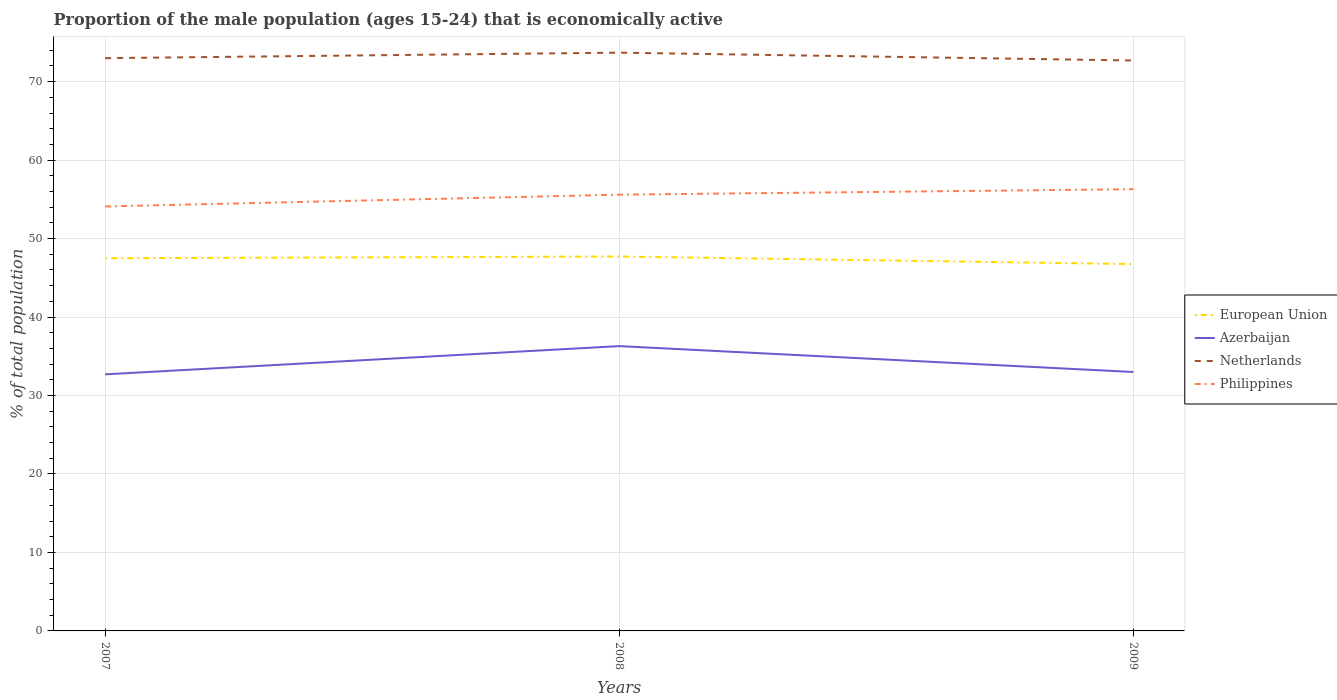How many different coloured lines are there?
Give a very brief answer. 4. Across all years, what is the maximum proportion of the male population that is economically active in Philippines?
Your response must be concise. 54.1. What is the total proportion of the male population that is economically active in Netherlands in the graph?
Your answer should be compact. -0.7. What is the difference between the highest and the second highest proportion of the male population that is economically active in Azerbaijan?
Keep it short and to the point. 3.6. Is the proportion of the male population that is economically active in Netherlands strictly greater than the proportion of the male population that is economically active in European Union over the years?
Your answer should be compact. No. What is the difference between two consecutive major ticks on the Y-axis?
Make the answer very short. 10. Does the graph contain grids?
Provide a succinct answer. Yes. How many legend labels are there?
Offer a terse response. 4. How are the legend labels stacked?
Ensure brevity in your answer.  Vertical. What is the title of the graph?
Make the answer very short. Proportion of the male population (ages 15-24) that is economically active. Does "New Zealand" appear as one of the legend labels in the graph?
Make the answer very short. No. What is the label or title of the X-axis?
Offer a very short reply. Years. What is the label or title of the Y-axis?
Provide a succinct answer. % of total population. What is the % of total population of European Union in 2007?
Give a very brief answer. 47.5. What is the % of total population in Azerbaijan in 2007?
Offer a terse response. 32.7. What is the % of total population in Philippines in 2007?
Your response must be concise. 54.1. What is the % of total population of European Union in 2008?
Your answer should be compact. 47.72. What is the % of total population of Azerbaijan in 2008?
Give a very brief answer. 36.3. What is the % of total population in Netherlands in 2008?
Your response must be concise. 73.7. What is the % of total population of Philippines in 2008?
Your answer should be very brief. 55.6. What is the % of total population in European Union in 2009?
Ensure brevity in your answer.  46.75. What is the % of total population in Netherlands in 2009?
Your response must be concise. 72.7. What is the % of total population in Philippines in 2009?
Your answer should be very brief. 56.3. Across all years, what is the maximum % of total population of European Union?
Provide a succinct answer. 47.72. Across all years, what is the maximum % of total population in Azerbaijan?
Keep it short and to the point. 36.3. Across all years, what is the maximum % of total population of Netherlands?
Give a very brief answer. 73.7. Across all years, what is the maximum % of total population of Philippines?
Keep it short and to the point. 56.3. Across all years, what is the minimum % of total population in European Union?
Provide a succinct answer. 46.75. Across all years, what is the minimum % of total population in Azerbaijan?
Offer a terse response. 32.7. Across all years, what is the minimum % of total population in Netherlands?
Your answer should be very brief. 72.7. Across all years, what is the minimum % of total population in Philippines?
Keep it short and to the point. 54.1. What is the total % of total population of European Union in the graph?
Provide a succinct answer. 141.97. What is the total % of total population in Azerbaijan in the graph?
Give a very brief answer. 102. What is the total % of total population of Netherlands in the graph?
Offer a terse response. 219.4. What is the total % of total population in Philippines in the graph?
Your response must be concise. 166. What is the difference between the % of total population of European Union in 2007 and that in 2008?
Provide a succinct answer. -0.22. What is the difference between the % of total population in Azerbaijan in 2007 and that in 2008?
Provide a short and direct response. -3.6. What is the difference between the % of total population in Netherlands in 2007 and that in 2008?
Your answer should be compact. -0.7. What is the difference between the % of total population in European Union in 2007 and that in 2009?
Make the answer very short. 0.74. What is the difference between the % of total population in European Union in 2008 and that in 2009?
Make the answer very short. 0.96. What is the difference between the % of total population of Azerbaijan in 2008 and that in 2009?
Your answer should be compact. 3.3. What is the difference between the % of total population of Netherlands in 2008 and that in 2009?
Your answer should be compact. 1. What is the difference between the % of total population of Philippines in 2008 and that in 2009?
Keep it short and to the point. -0.7. What is the difference between the % of total population of European Union in 2007 and the % of total population of Azerbaijan in 2008?
Your response must be concise. 11.2. What is the difference between the % of total population in European Union in 2007 and the % of total population in Netherlands in 2008?
Your answer should be very brief. -26.2. What is the difference between the % of total population of European Union in 2007 and the % of total population of Philippines in 2008?
Your answer should be compact. -8.1. What is the difference between the % of total population in Azerbaijan in 2007 and the % of total population in Netherlands in 2008?
Provide a short and direct response. -41. What is the difference between the % of total population in Azerbaijan in 2007 and the % of total population in Philippines in 2008?
Your response must be concise. -22.9. What is the difference between the % of total population in European Union in 2007 and the % of total population in Azerbaijan in 2009?
Your answer should be compact. 14.5. What is the difference between the % of total population of European Union in 2007 and the % of total population of Netherlands in 2009?
Keep it short and to the point. -25.2. What is the difference between the % of total population of European Union in 2007 and the % of total population of Philippines in 2009?
Offer a very short reply. -8.8. What is the difference between the % of total population in Azerbaijan in 2007 and the % of total population in Netherlands in 2009?
Your answer should be very brief. -40. What is the difference between the % of total population in Azerbaijan in 2007 and the % of total population in Philippines in 2009?
Provide a succinct answer. -23.6. What is the difference between the % of total population of European Union in 2008 and the % of total population of Azerbaijan in 2009?
Give a very brief answer. 14.72. What is the difference between the % of total population of European Union in 2008 and the % of total population of Netherlands in 2009?
Your response must be concise. -24.98. What is the difference between the % of total population in European Union in 2008 and the % of total population in Philippines in 2009?
Make the answer very short. -8.58. What is the difference between the % of total population in Azerbaijan in 2008 and the % of total population in Netherlands in 2009?
Ensure brevity in your answer.  -36.4. What is the difference between the % of total population in Azerbaijan in 2008 and the % of total population in Philippines in 2009?
Offer a very short reply. -20. What is the difference between the % of total population in Netherlands in 2008 and the % of total population in Philippines in 2009?
Offer a terse response. 17.4. What is the average % of total population of European Union per year?
Offer a terse response. 47.32. What is the average % of total population in Netherlands per year?
Your answer should be very brief. 73.13. What is the average % of total population in Philippines per year?
Offer a very short reply. 55.33. In the year 2007, what is the difference between the % of total population in European Union and % of total population in Azerbaijan?
Your response must be concise. 14.8. In the year 2007, what is the difference between the % of total population of European Union and % of total population of Netherlands?
Offer a very short reply. -25.5. In the year 2007, what is the difference between the % of total population of European Union and % of total population of Philippines?
Provide a short and direct response. -6.6. In the year 2007, what is the difference between the % of total population of Azerbaijan and % of total population of Netherlands?
Your answer should be compact. -40.3. In the year 2007, what is the difference between the % of total population in Azerbaijan and % of total population in Philippines?
Your answer should be compact. -21.4. In the year 2008, what is the difference between the % of total population in European Union and % of total population in Azerbaijan?
Offer a terse response. 11.42. In the year 2008, what is the difference between the % of total population of European Union and % of total population of Netherlands?
Keep it short and to the point. -25.98. In the year 2008, what is the difference between the % of total population in European Union and % of total population in Philippines?
Your response must be concise. -7.88. In the year 2008, what is the difference between the % of total population of Azerbaijan and % of total population of Netherlands?
Keep it short and to the point. -37.4. In the year 2008, what is the difference between the % of total population of Azerbaijan and % of total population of Philippines?
Provide a short and direct response. -19.3. In the year 2008, what is the difference between the % of total population in Netherlands and % of total population in Philippines?
Your answer should be very brief. 18.1. In the year 2009, what is the difference between the % of total population of European Union and % of total population of Azerbaijan?
Your response must be concise. 13.75. In the year 2009, what is the difference between the % of total population in European Union and % of total population in Netherlands?
Offer a terse response. -25.95. In the year 2009, what is the difference between the % of total population of European Union and % of total population of Philippines?
Give a very brief answer. -9.55. In the year 2009, what is the difference between the % of total population in Azerbaijan and % of total population in Netherlands?
Offer a terse response. -39.7. In the year 2009, what is the difference between the % of total population in Azerbaijan and % of total population in Philippines?
Offer a very short reply. -23.3. In the year 2009, what is the difference between the % of total population in Netherlands and % of total population in Philippines?
Your answer should be compact. 16.4. What is the ratio of the % of total population in Azerbaijan in 2007 to that in 2008?
Your answer should be compact. 0.9. What is the ratio of the % of total population in European Union in 2007 to that in 2009?
Offer a terse response. 1.02. What is the ratio of the % of total population of Azerbaijan in 2007 to that in 2009?
Provide a succinct answer. 0.99. What is the ratio of the % of total population in Netherlands in 2007 to that in 2009?
Ensure brevity in your answer.  1. What is the ratio of the % of total population in Philippines in 2007 to that in 2009?
Offer a terse response. 0.96. What is the ratio of the % of total population in European Union in 2008 to that in 2009?
Provide a short and direct response. 1.02. What is the ratio of the % of total population in Azerbaijan in 2008 to that in 2009?
Ensure brevity in your answer.  1.1. What is the ratio of the % of total population of Netherlands in 2008 to that in 2009?
Offer a very short reply. 1.01. What is the ratio of the % of total population in Philippines in 2008 to that in 2009?
Ensure brevity in your answer.  0.99. What is the difference between the highest and the second highest % of total population in European Union?
Provide a short and direct response. 0.22. What is the difference between the highest and the second highest % of total population of Azerbaijan?
Offer a very short reply. 3.3. What is the difference between the highest and the second highest % of total population in Philippines?
Give a very brief answer. 0.7. What is the difference between the highest and the lowest % of total population in European Union?
Provide a short and direct response. 0.96. What is the difference between the highest and the lowest % of total population in Philippines?
Make the answer very short. 2.2. 